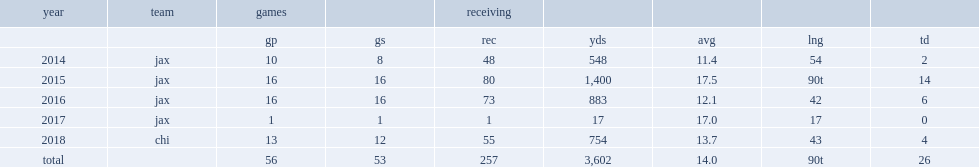How many touchdowns did robinson get in 2018? 4.0. 